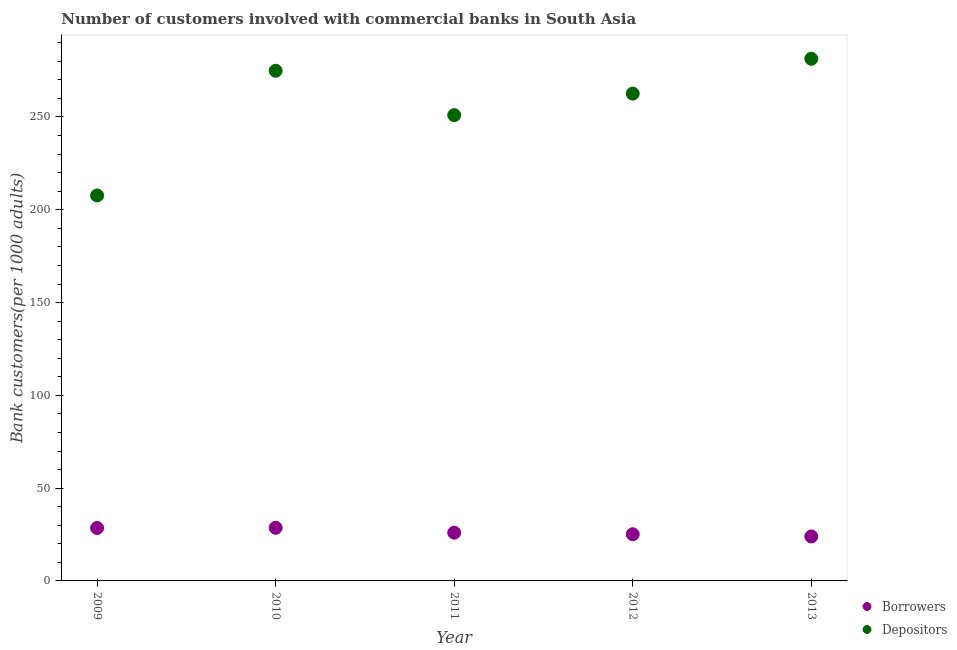Is the number of dotlines equal to the number of legend labels?
Your answer should be compact. Yes. What is the number of borrowers in 2009?
Make the answer very short. 28.52. Across all years, what is the maximum number of depositors?
Your answer should be very brief. 281.38. Across all years, what is the minimum number of borrowers?
Give a very brief answer. 23.97. In which year was the number of depositors maximum?
Keep it short and to the point. 2013. In which year was the number of borrowers minimum?
Keep it short and to the point. 2013. What is the total number of depositors in the graph?
Give a very brief answer. 1277.59. What is the difference between the number of borrowers in 2011 and that in 2012?
Give a very brief answer. 0.86. What is the difference between the number of borrowers in 2012 and the number of depositors in 2009?
Offer a terse response. -182.56. What is the average number of depositors per year?
Your answer should be very brief. 255.52. In the year 2013, what is the difference between the number of depositors and number of borrowers?
Give a very brief answer. 257.41. What is the ratio of the number of depositors in 2010 to that in 2013?
Offer a terse response. 0.98. Is the difference between the number of borrowers in 2009 and 2013 greater than the difference between the number of depositors in 2009 and 2013?
Your answer should be compact. Yes. What is the difference between the highest and the second highest number of borrowers?
Your response must be concise. 0.12. What is the difference between the highest and the lowest number of borrowers?
Provide a succinct answer. 4.68. In how many years, is the number of borrowers greater than the average number of borrowers taken over all years?
Keep it short and to the point. 2. Is the sum of the number of borrowers in 2009 and 2010 greater than the maximum number of depositors across all years?
Provide a succinct answer. No. Does the number of borrowers monotonically increase over the years?
Keep it short and to the point. No. Is the number of depositors strictly greater than the number of borrowers over the years?
Offer a terse response. Yes. Is the number of borrowers strictly less than the number of depositors over the years?
Provide a short and direct response. Yes. How many years are there in the graph?
Ensure brevity in your answer.  5. Does the graph contain any zero values?
Keep it short and to the point. No. How are the legend labels stacked?
Offer a terse response. Vertical. What is the title of the graph?
Offer a terse response. Number of customers involved with commercial banks in South Asia. What is the label or title of the Y-axis?
Provide a short and direct response. Bank customers(per 1000 adults). What is the Bank customers(per 1000 adults) of Borrowers in 2009?
Offer a terse response. 28.52. What is the Bank customers(per 1000 adults) of Depositors in 2009?
Give a very brief answer. 207.71. What is the Bank customers(per 1000 adults) of Borrowers in 2010?
Your answer should be very brief. 28.64. What is the Bank customers(per 1000 adults) of Depositors in 2010?
Offer a very short reply. 274.9. What is the Bank customers(per 1000 adults) in Borrowers in 2011?
Your answer should be very brief. 26.01. What is the Bank customers(per 1000 adults) in Depositors in 2011?
Make the answer very short. 250.99. What is the Bank customers(per 1000 adults) of Borrowers in 2012?
Provide a succinct answer. 25.15. What is the Bank customers(per 1000 adults) of Depositors in 2012?
Your response must be concise. 262.6. What is the Bank customers(per 1000 adults) in Borrowers in 2013?
Provide a succinct answer. 23.97. What is the Bank customers(per 1000 adults) of Depositors in 2013?
Ensure brevity in your answer.  281.38. Across all years, what is the maximum Bank customers(per 1000 adults) in Borrowers?
Ensure brevity in your answer.  28.64. Across all years, what is the maximum Bank customers(per 1000 adults) in Depositors?
Your response must be concise. 281.38. Across all years, what is the minimum Bank customers(per 1000 adults) in Borrowers?
Offer a very short reply. 23.97. Across all years, what is the minimum Bank customers(per 1000 adults) in Depositors?
Keep it short and to the point. 207.71. What is the total Bank customers(per 1000 adults) of Borrowers in the graph?
Your answer should be compact. 132.29. What is the total Bank customers(per 1000 adults) of Depositors in the graph?
Ensure brevity in your answer.  1277.59. What is the difference between the Bank customers(per 1000 adults) in Borrowers in 2009 and that in 2010?
Make the answer very short. -0.12. What is the difference between the Bank customers(per 1000 adults) in Depositors in 2009 and that in 2010?
Provide a succinct answer. -67.19. What is the difference between the Bank customers(per 1000 adults) in Borrowers in 2009 and that in 2011?
Ensure brevity in your answer.  2.51. What is the difference between the Bank customers(per 1000 adults) of Depositors in 2009 and that in 2011?
Ensure brevity in your answer.  -43.28. What is the difference between the Bank customers(per 1000 adults) in Borrowers in 2009 and that in 2012?
Offer a very short reply. 3.37. What is the difference between the Bank customers(per 1000 adults) in Depositors in 2009 and that in 2012?
Provide a succinct answer. -54.89. What is the difference between the Bank customers(per 1000 adults) in Borrowers in 2009 and that in 2013?
Your answer should be very brief. 4.55. What is the difference between the Bank customers(per 1000 adults) of Depositors in 2009 and that in 2013?
Keep it short and to the point. -73.67. What is the difference between the Bank customers(per 1000 adults) in Borrowers in 2010 and that in 2011?
Your answer should be very brief. 2.63. What is the difference between the Bank customers(per 1000 adults) in Depositors in 2010 and that in 2011?
Your response must be concise. 23.91. What is the difference between the Bank customers(per 1000 adults) of Borrowers in 2010 and that in 2012?
Keep it short and to the point. 3.49. What is the difference between the Bank customers(per 1000 adults) in Depositors in 2010 and that in 2012?
Keep it short and to the point. 12.31. What is the difference between the Bank customers(per 1000 adults) in Borrowers in 2010 and that in 2013?
Your response must be concise. 4.68. What is the difference between the Bank customers(per 1000 adults) of Depositors in 2010 and that in 2013?
Your answer should be compact. -6.48. What is the difference between the Bank customers(per 1000 adults) in Borrowers in 2011 and that in 2012?
Keep it short and to the point. 0.86. What is the difference between the Bank customers(per 1000 adults) of Depositors in 2011 and that in 2012?
Your answer should be compact. -11.61. What is the difference between the Bank customers(per 1000 adults) of Borrowers in 2011 and that in 2013?
Ensure brevity in your answer.  2.04. What is the difference between the Bank customers(per 1000 adults) of Depositors in 2011 and that in 2013?
Your response must be concise. -30.39. What is the difference between the Bank customers(per 1000 adults) in Borrowers in 2012 and that in 2013?
Offer a terse response. 1.18. What is the difference between the Bank customers(per 1000 adults) in Depositors in 2012 and that in 2013?
Your response must be concise. -18.78. What is the difference between the Bank customers(per 1000 adults) in Borrowers in 2009 and the Bank customers(per 1000 adults) in Depositors in 2010?
Your answer should be very brief. -246.38. What is the difference between the Bank customers(per 1000 adults) in Borrowers in 2009 and the Bank customers(per 1000 adults) in Depositors in 2011?
Your answer should be very brief. -222.47. What is the difference between the Bank customers(per 1000 adults) of Borrowers in 2009 and the Bank customers(per 1000 adults) of Depositors in 2012?
Your answer should be compact. -234.08. What is the difference between the Bank customers(per 1000 adults) in Borrowers in 2009 and the Bank customers(per 1000 adults) in Depositors in 2013?
Keep it short and to the point. -252.86. What is the difference between the Bank customers(per 1000 adults) in Borrowers in 2010 and the Bank customers(per 1000 adults) in Depositors in 2011?
Your response must be concise. -222.35. What is the difference between the Bank customers(per 1000 adults) of Borrowers in 2010 and the Bank customers(per 1000 adults) of Depositors in 2012?
Offer a terse response. -233.96. What is the difference between the Bank customers(per 1000 adults) of Borrowers in 2010 and the Bank customers(per 1000 adults) of Depositors in 2013?
Make the answer very short. -252.74. What is the difference between the Bank customers(per 1000 adults) in Borrowers in 2011 and the Bank customers(per 1000 adults) in Depositors in 2012?
Your answer should be compact. -236.59. What is the difference between the Bank customers(per 1000 adults) of Borrowers in 2011 and the Bank customers(per 1000 adults) of Depositors in 2013?
Ensure brevity in your answer.  -255.37. What is the difference between the Bank customers(per 1000 adults) of Borrowers in 2012 and the Bank customers(per 1000 adults) of Depositors in 2013?
Provide a succinct answer. -256.23. What is the average Bank customers(per 1000 adults) of Borrowers per year?
Provide a short and direct response. 26.46. What is the average Bank customers(per 1000 adults) of Depositors per year?
Your response must be concise. 255.52. In the year 2009, what is the difference between the Bank customers(per 1000 adults) of Borrowers and Bank customers(per 1000 adults) of Depositors?
Provide a succinct answer. -179.19. In the year 2010, what is the difference between the Bank customers(per 1000 adults) in Borrowers and Bank customers(per 1000 adults) in Depositors?
Ensure brevity in your answer.  -246.26. In the year 2011, what is the difference between the Bank customers(per 1000 adults) of Borrowers and Bank customers(per 1000 adults) of Depositors?
Provide a short and direct response. -224.98. In the year 2012, what is the difference between the Bank customers(per 1000 adults) in Borrowers and Bank customers(per 1000 adults) in Depositors?
Keep it short and to the point. -237.45. In the year 2013, what is the difference between the Bank customers(per 1000 adults) in Borrowers and Bank customers(per 1000 adults) in Depositors?
Your answer should be compact. -257.41. What is the ratio of the Bank customers(per 1000 adults) of Depositors in 2009 to that in 2010?
Your answer should be compact. 0.76. What is the ratio of the Bank customers(per 1000 adults) of Borrowers in 2009 to that in 2011?
Your answer should be very brief. 1.1. What is the ratio of the Bank customers(per 1000 adults) in Depositors in 2009 to that in 2011?
Ensure brevity in your answer.  0.83. What is the ratio of the Bank customers(per 1000 adults) in Borrowers in 2009 to that in 2012?
Provide a succinct answer. 1.13. What is the ratio of the Bank customers(per 1000 adults) of Depositors in 2009 to that in 2012?
Give a very brief answer. 0.79. What is the ratio of the Bank customers(per 1000 adults) in Borrowers in 2009 to that in 2013?
Make the answer very short. 1.19. What is the ratio of the Bank customers(per 1000 adults) of Depositors in 2009 to that in 2013?
Ensure brevity in your answer.  0.74. What is the ratio of the Bank customers(per 1000 adults) of Borrowers in 2010 to that in 2011?
Offer a very short reply. 1.1. What is the ratio of the Bank customers(per 1000 adults) in Depositors in 2010 to that in 2011?
Give a very brief answer. 1.1. What is the ratio of the Bank customers(per 1000 adults) of Borrowers in 2010 to that in 2012?
Offer a very short reply. 1.14. What is the ratio of the Bank customers(per 1000 adults) in Depositors in 2010 to that in 2012?
Your response must be concise. 1.05. What is the ratio of the Bank customers(per 1000 adults) of Borrowers in 2010 to that in 2013?
Your answer should be compact. 1.2. What is the ratio of the Bank customers(per 1000 adults) of Borrowers in 2011 to that in 2012?
Offer a terse response. 1.03. What is the ratio of the Bank customers(per 1000 adults) in Depositors in 2011 to that in 2012?
Offer a terse response. 0.96. What is the ratio of the Bank customers(per 1000 adults) in Borrowers in 2011 to that in 2013?
Ensure brevity in your answer.  1.09. What is the ratio of the Bank customers(per 1000 adults) of Depositors in 2011 to that in 2013?
Your answer should be very brief. 0.89. What is the ratio of the Bank customers(per 1000 adults) of Borrowers in 2012 to that in 2013?
Ensure brevity in your answer.  1.05. What is the difference between the highest and the second highest Bank customers(per 1000 adults) in Borrowers?
Make the answer very short. 0.12. What is the difference between the highest and the second highest Bank customers(per 1000 adults) of Depositors?
Offer a terse response. 6.48. What is the difference between the highest and the lowest Bank customers(per 1000 adults) of Borrowers?
Your answer should be compact. 4.68. What is the difference between the highest and the lowest Bank customers(per 1000 adults) in Depositors?
Your response must be concise. 73.67. 